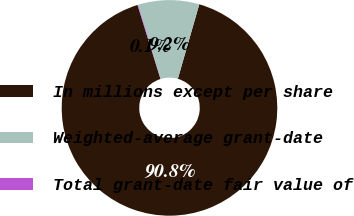Convert chart. <chart><loc_0><loc_0><loc_500><loc_500><pie_chart><fcel>In millions except per share<fcel>Weighted-average grant-date<fcel>Total grant-date fair value of<nl><fcel>90.75%<fcel>9.16%<fcel>0.09%<nl></chart> 